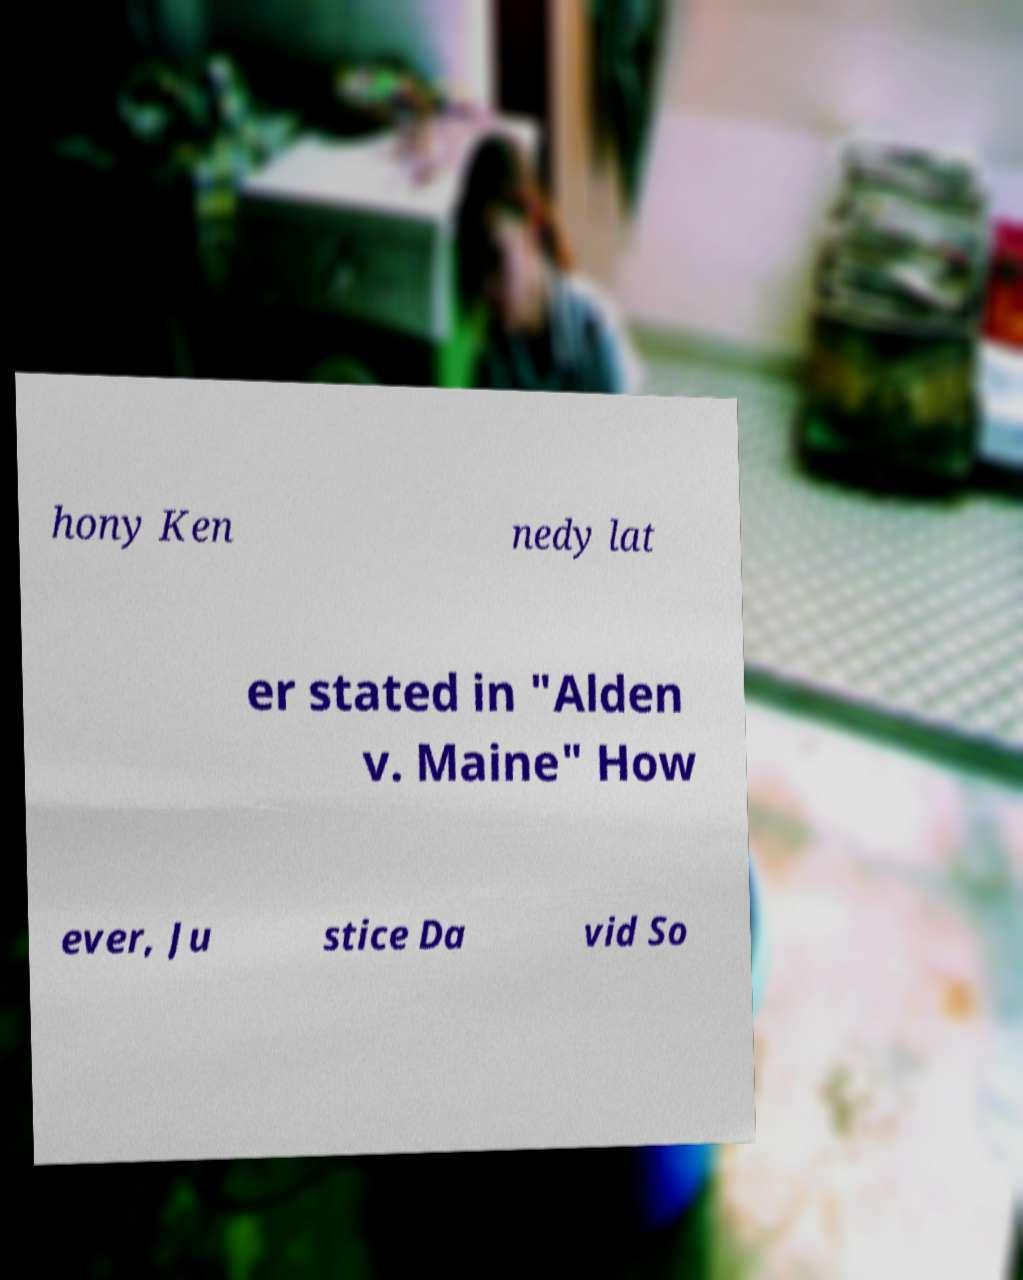Can you accurately transcribe the text from the provided image for me? hony Ken nedy lat er stated in "Alden v. Maine" How ever, Ju stice Da vid So 